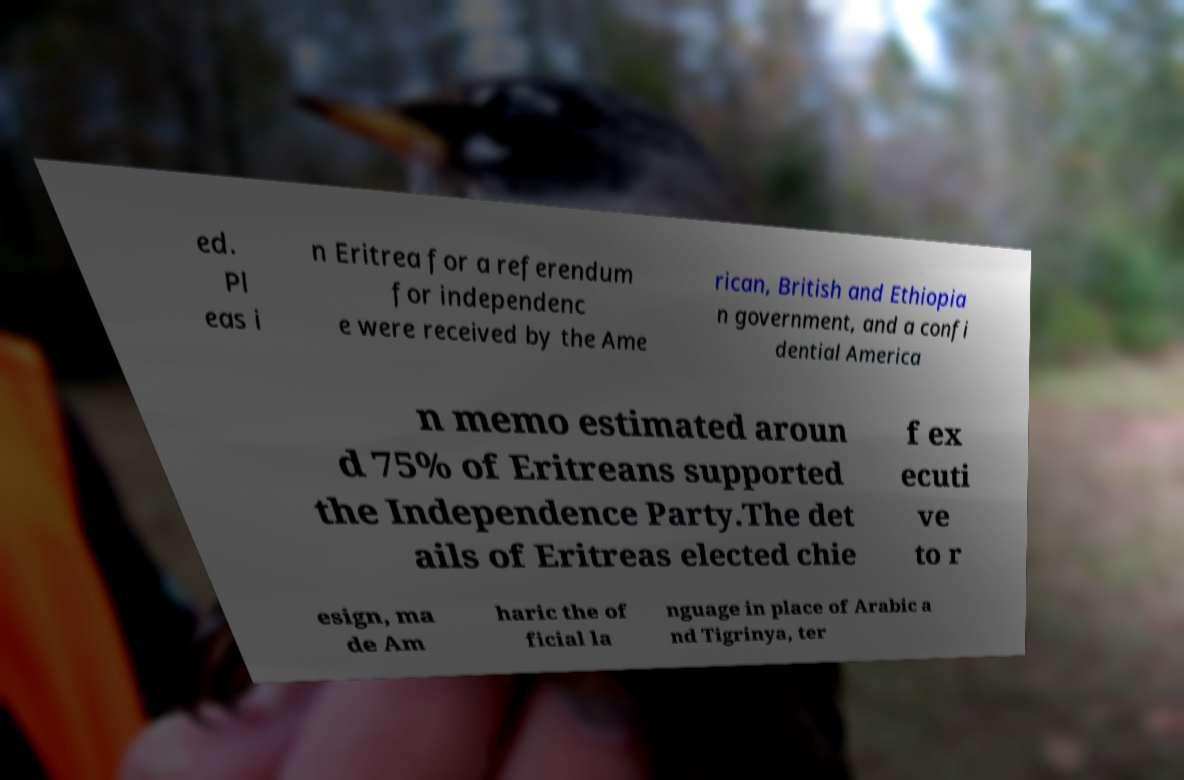Can you accurately transcribe the text from the provided image for me? ed. Pl eas i n Eritrea for a referendum for independenc e were received by the Ame rican, British and Ethiopia n government, and a confi dential America n memo estimated aroun d 75% of Eritreans supported the Independence Party.The det ails of Eritreas elected chie f ex ecuti ve to r esign, ma de Am haric the of ficial la nguage in place of Arabic a nd Tigrinya, ter 